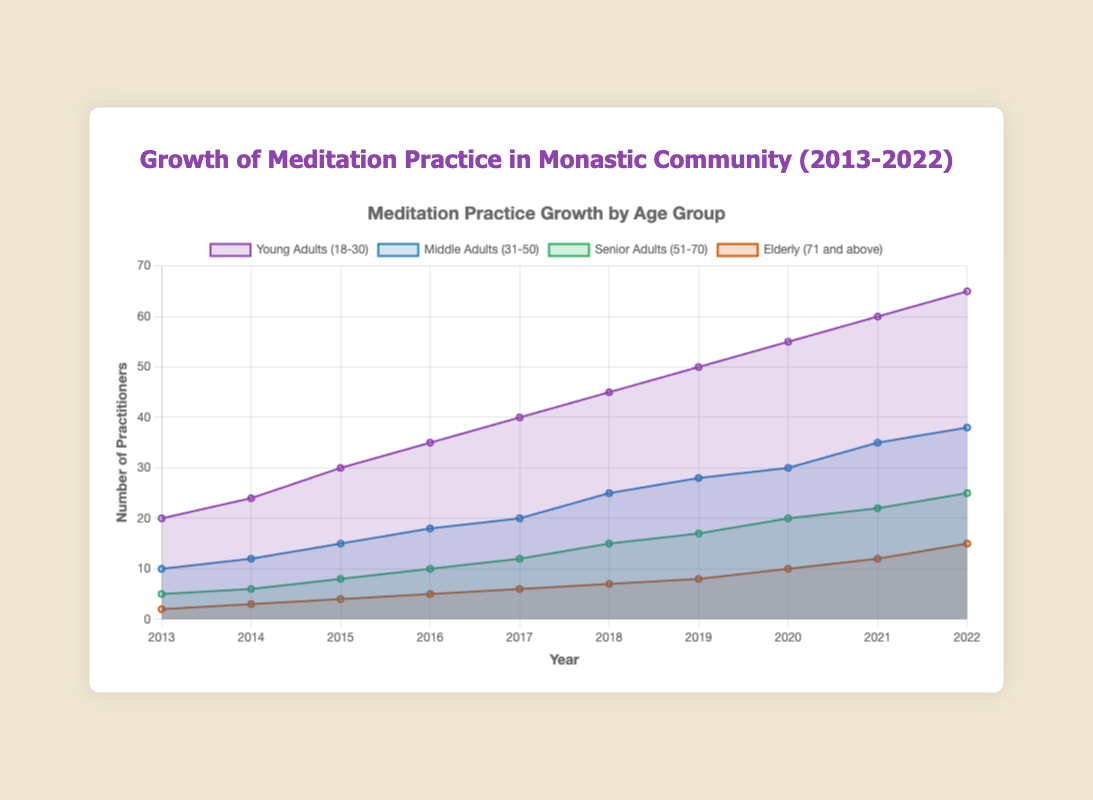What is the title of the chart? The title is located at the top center of the chart, and it reads "Meditation Practice Growth by Age Group".
Answer: Meditation Practice Growth by Age Group Which age group had the highest number of practitioners in 2022? By looking at the endpoints of each line on the chart for the year 2022, the group "Young Adults (18-30)" has the highest end value of 65 practitioners.
Answer: Young Adults (18-30) How many years are displayed on the x-axis? The x-axis spans from 2013 to 2022 inclusively. Counting each year, there are 10 years displayed.
Answer: 10 What is the color used to represent the "Senior Adults (51-70)" age group? The color legend indicates that "Senior Adults (51-70)" are represented with a green shade.
Answer: Green Between 2015 and 2018, which age group saw the most significant increase in the number of practitioners? By comparing the vertical differences in the graph between 2015 and 2018, "Young Adults (18-30)" increased from 30 to 45 practitioners, which is the most significant increase of 15 practitioners.
Answer: Young Adults (18-30) Which age group had the slowest growth rate over the decade? The "Elderly (71 and above)" group starts with 2 practitioners in 2013 and ends with 15 in 2022. Comparing this to other groups, this growth is the slowest.
Answer: Elderly (71 and above) How many practitioners were there in total across all age groups in 2019? Sum the values for 2019: Young Adults (50) + Middle Adults (28) + Senior Adults (17) + Elderly (8) = 103 practitioners.
Answer: 103 What is the difference in the number of practitioners between "Young Adults (18-30)" and "Middle Adults (31-50)" at the end of 2022? Looking at the values for 2022, Young Adults have 65 practitioners and Middle Adults have 38 practitioners. The difference is 65 - 38 = 27 practitioners.
Answer: 27 Which age group shows a consistent increase with no declines over the entire decade? All age groups show consistent increases, but to verify, we can track each line upwards year over year and confirm no declines in any group.
Answer: All groups What was the total number of practitioners in 2016, and how does it compare to 2022? Sum the values for 2016: Young Adults (35) + Middle Adults (18) + Senior Adults (10) + Elderly (5) = 68 practitioners. For 2022, sum of: Young Adults (65) + Middle Adults (38) + Senior Adults (25) + Elderly (15) = 143 practitioners. The difference is 143 - 68 = 75 more practitioners in 2022.
Answer: 75 more in 2022 